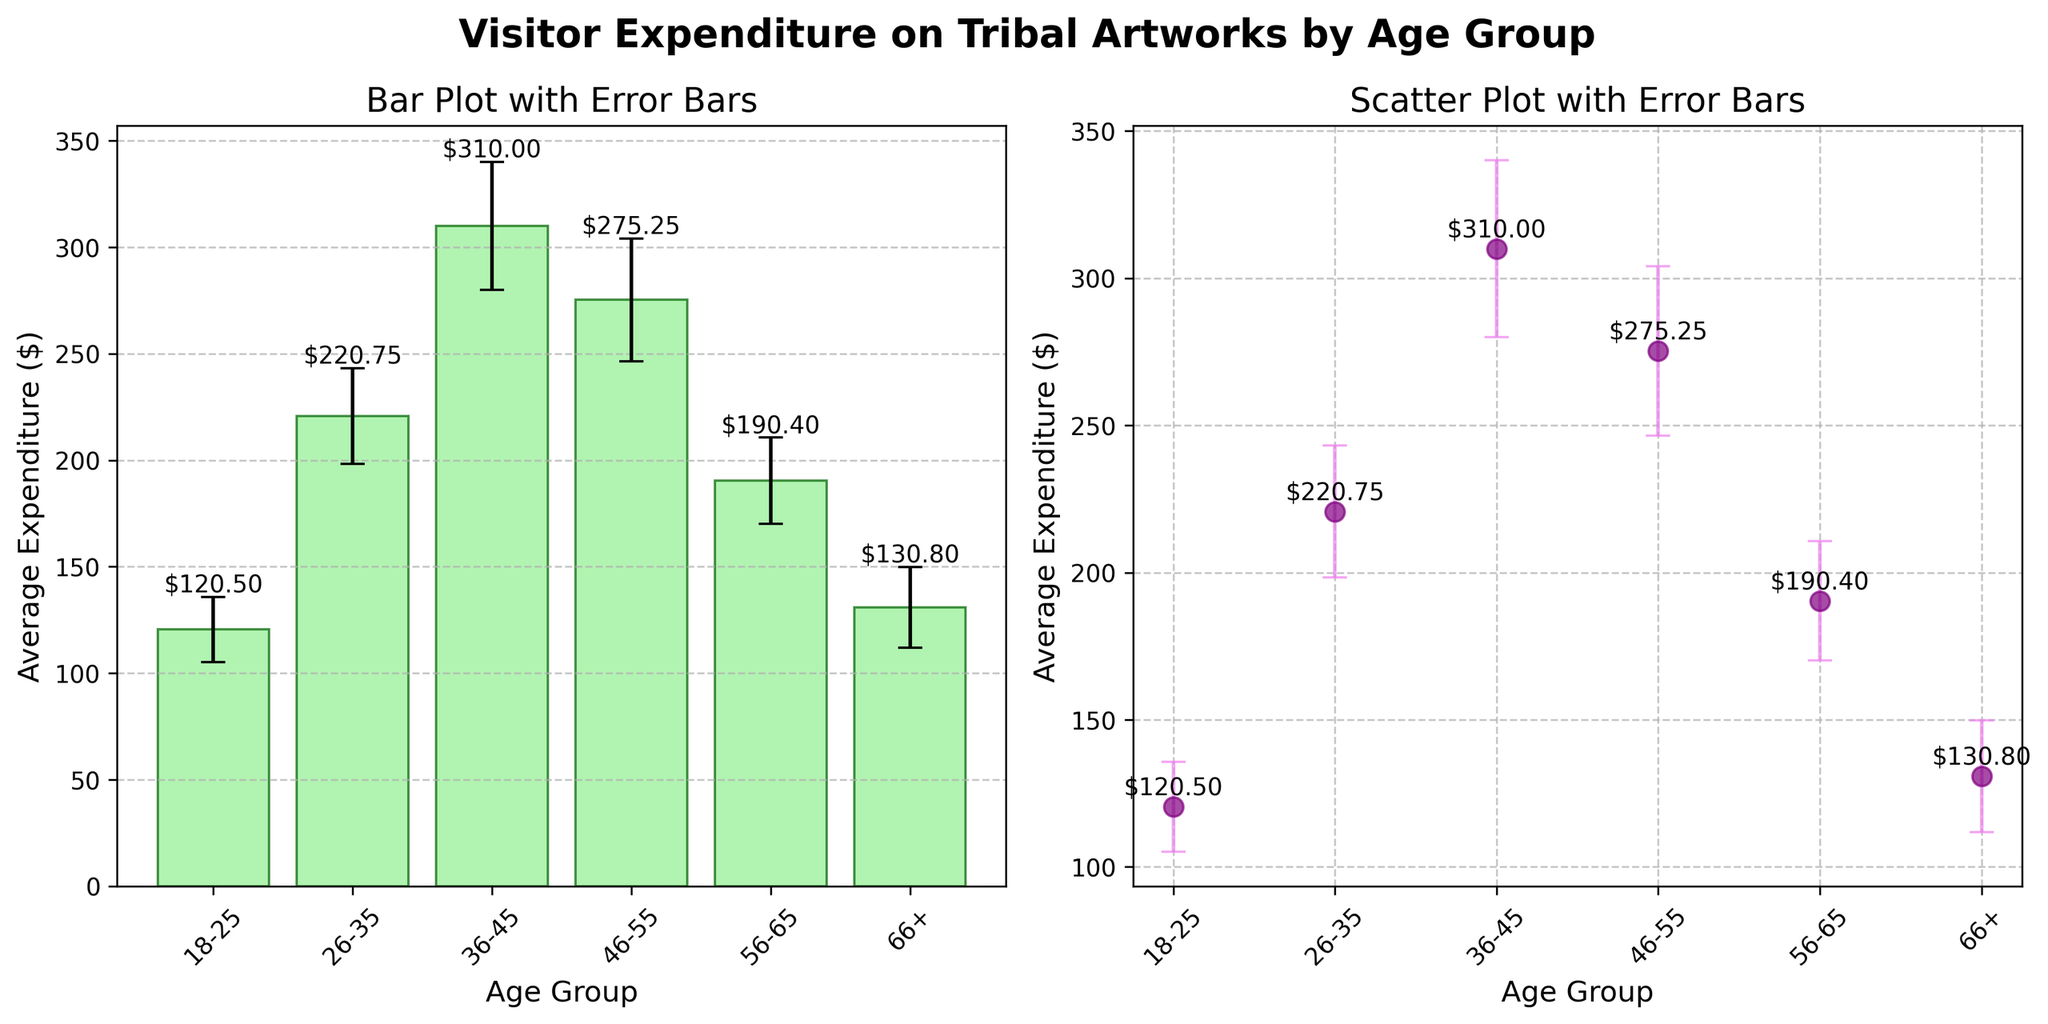What's the average expenditure for the 36-45 age group? The bar for the 36-45 age group is labeled with an average expenditure of $310.00.
Answer: 310.00 What is the title of the bar plot section in the figure? The title above the bar plot section is "Bar Plot with Error Bars".
Answer: Bar Plot with Error Bars How much is the standard deviation for the 66+ age group? The standard deviation for the 66+ age group is shown as a vertical error bar in the graphs, marked at 18.95.
Answer: 18.95 Which age group spends the most on tribal artworks on average? By comparing the heights and labels of the bars in the bar plot, the 36-45 age group has the highest average expenditure of $310.00.
Answer: 36-45 What is the difference in average expenditure between the 26-35 and 56-65 age groups? The average expenditures are $220.75 and $190.40 for the 26-35 and 56-65 age groups respectively. The difference is $220.75 - $190.40.
Answer: 30.35 Which age group has the smallest standard deviation in their expenditure? By observing the lengths of error bars, the 18-25 age group has the smallest standard deviation of 15.30.
Answer: 18-25 How do the error bars help in interpreting the data? Error bars show the variability or uncertainty in the average expenditure data, indicating the standard deviations. They visually display the range through which the average value can vary.
Answer: They show variability In the scatter plot, what color represents the error bars? The error bars in the scatter plot are colored violet.
Answer: violet How does the expenditure change as the age progresses beyond 45? The average expenditure increases up to the 36-45 age group and then decreases for older age groups (46-55, 56-65, and 66+).
Answer: Increases then decreases Which age group has an average expenditure closest to $200? The 56-65 age group has an average expenditure of $190.40, which is closest to $200.
Answer: 56-65 